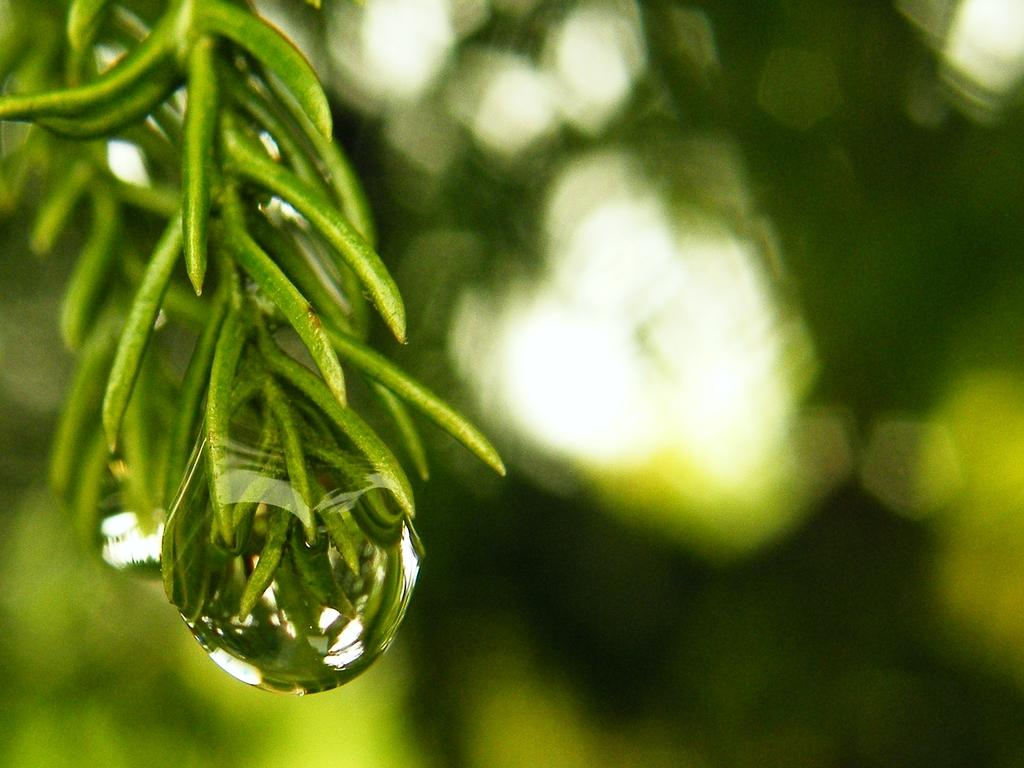What is the main subject of the image? The main subject of the image is a plant. Can you describe any specific details about the plant? There is a water drop on the plant in the image. How does the plant help reduce friction in the image? The image does not show any friction or the plant's ability to reduce it. 